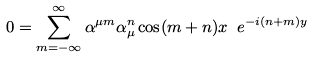<formula> <loc_0><loc_0><loc_500><loc_500>0 = \sum _ { m = - \infty } ^ { \infty } \alpha ^ { \mu m } \alpha _ { \mu } ^ { n } \cos ( m + n ) x \ e ^ { - i ( n + m ) y }</formula> 